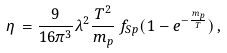Convert formula to latex. <formula><loc_0><loc_0><loc_500><loc_500>\eta \, = \frac { 9 } { 1 6 \pi ^ { 3 } } \lambda ^ { 2 } \frac { T ^ { 2 } } { m _ { p } } \, f _ { S p } ( 1 - e ^ { - \frac { m _ { p } } { T } } ) \, ,</formula> 